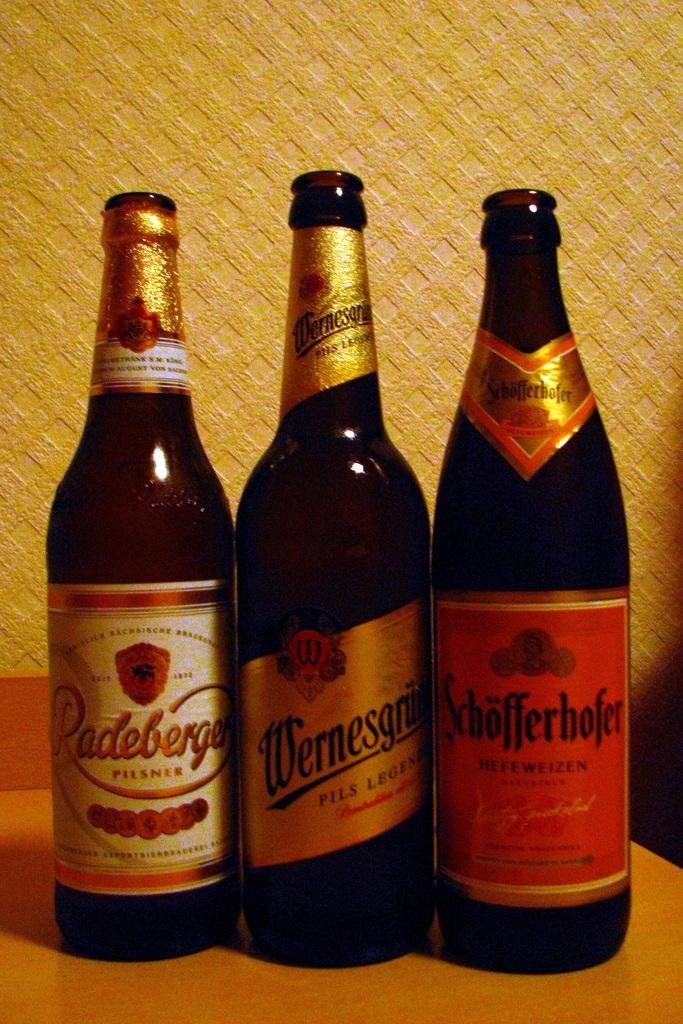<image>
Present a compact description of the photo's key features. Three opened dark bottles, including a bottle of Pilsner, sit on a table. 